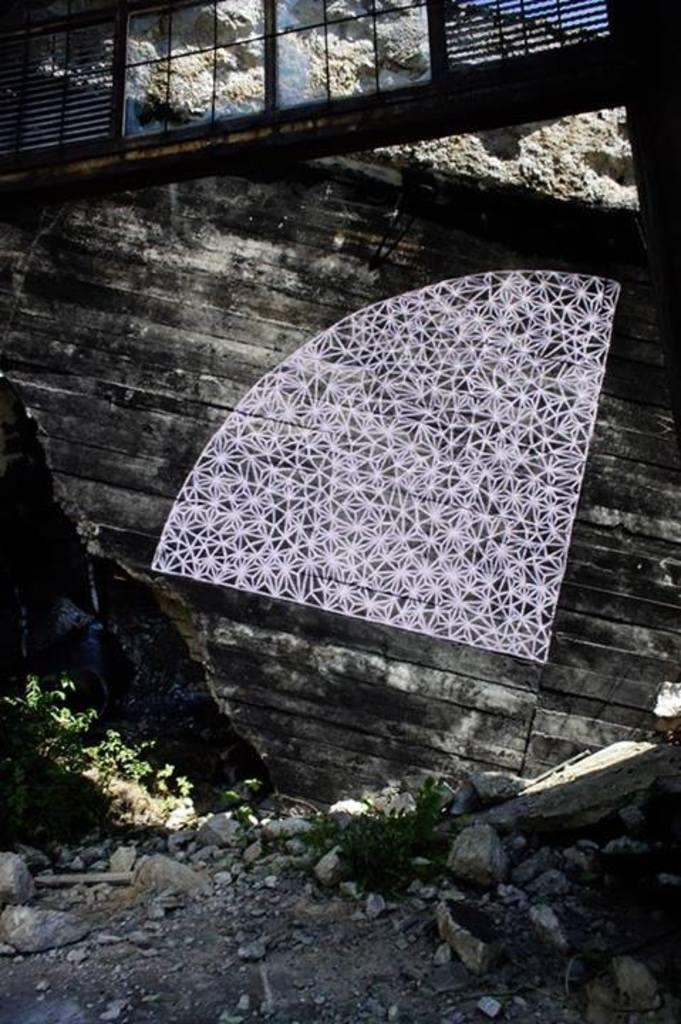What type of natural elements can be seen in the image? There are plants and rocks in the image. What type of material is used for the wall in the image? There is a wooden wall in the image. Can you describe any other objects present in the image? There are unspecified objects in the image. What type of wound can be seen on the button in the image? There is no button or wound present in the image. What type of thrill can be experienced by the plants in the image? Plants do not experience thrill, as they are inanimate objects. 